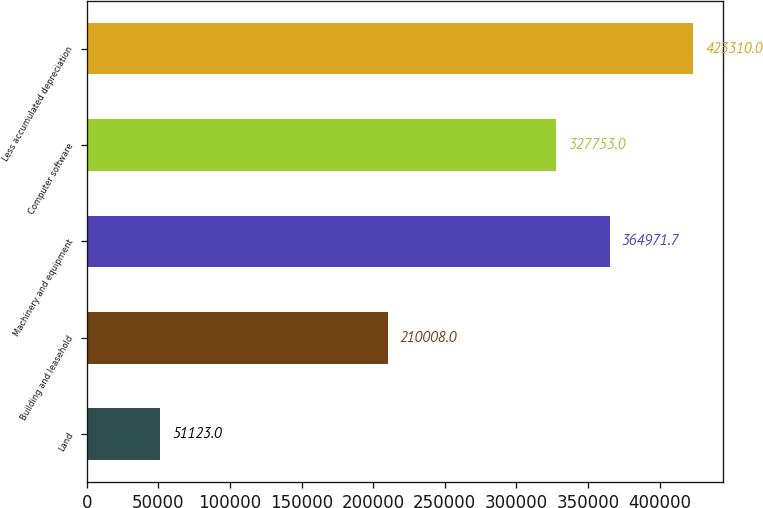<chart> <loc_0><loc_0><loc_500><loc_500><bar_chart><fcel>Land<fcel>Building and leasehold<fcel>Machinery and equipment<fcel>Computer software<fcel>Less accumulated depreciation<nl><fcel>51123<fcel>210008<fcel>364972<fcel>327753<fcel>423310<nl></chart> 